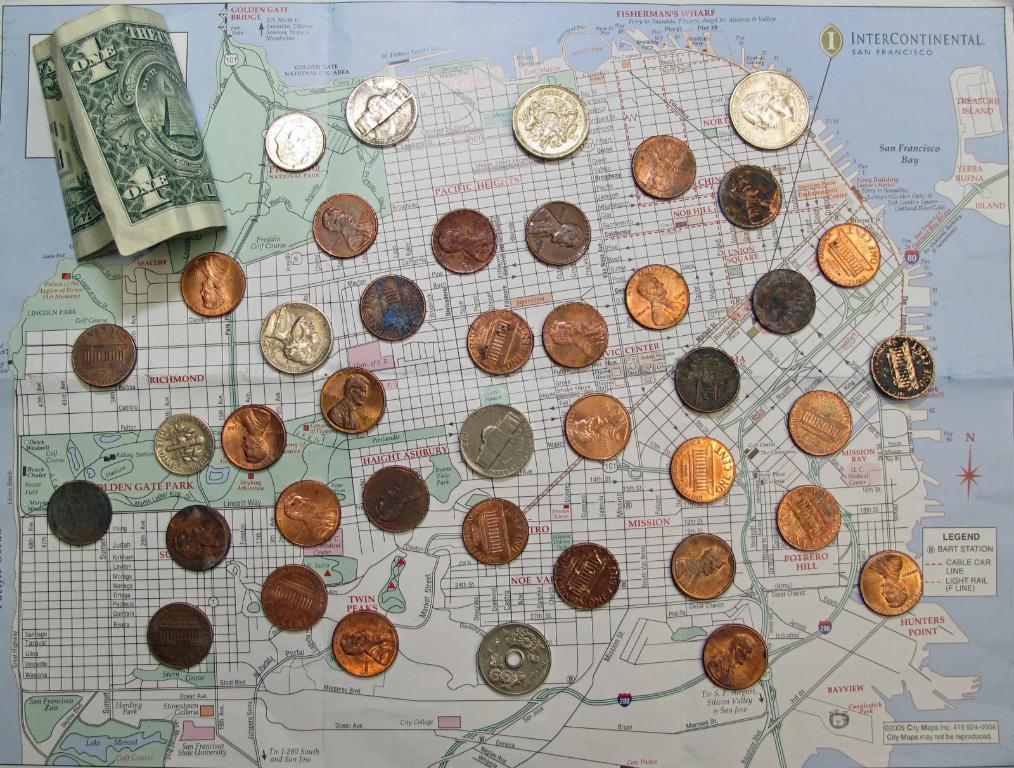What number is on the bill?
Your response must be concise. 1. What is the value of the copper coin?
Keep it short and to the point. 1 cent. 